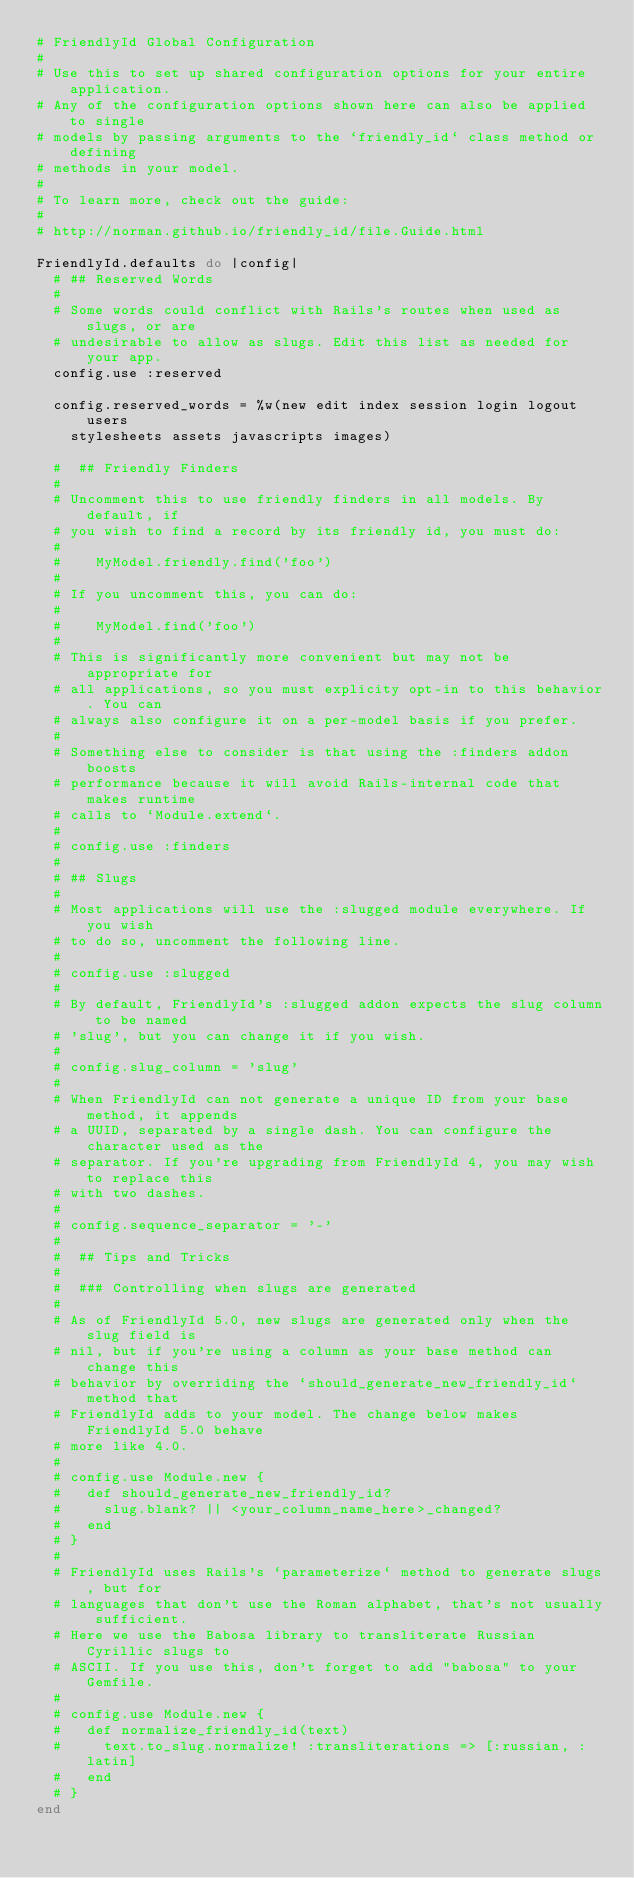Convert code to text. <code><loc_0><loc_0><loc_500><loc_500><_Ruby_># FriendlyId Global Configuration
#
# Use this to set up shared configuration options for your entire application.
# Any of the configuration options shown here can also be applied to single
# models by passing arguments to the `friendly_id` class method or defining
# methods in your model.
#
# To learn more, check out the guide:
#
# http://norman.github.io/friendly_id/file.Guide.html

FriendlyId.defaults do |config|
  # ## Reserved Words
  #
  # Some words could conflict with Rails's routes when used as slugs, or are
  # undesirable to allow as slugs. Edit this list as needed for your app.
  config.use :reserved

  config.reserved_words = %w(new edit index session login logout users
    stylesheets assets javascripts images)

  #  ## Friendly Finders
  #
  # Uncomment this to use friendly finders in all models. By default, if
  # you wish to find a record by its friendly id, you must do:
  #
  #    MyModel.friendly.find('foo')
  #
  # If you uncomment this, you can do:
  #
  #    MyModel.find('foo')
  #
  # This is significantly more convenient but may not be appropriate for
  # all applications, so you must explicity opt-in to this behavior. You can
  # always also configure it on a per-model basis if you prefer.
  #
  # Something else to consider is that using the :finders addon boosts
  # performance because it will avoid Rails-internal code that makes runtime
  # calls to `Module.extend`.
  #
  # config.use :finders
  #
  # ## Slugs
  #
  # Most applications will use the :slugged module everywhere. If you wish
  # to do so, uncomment the following line.
  #
  # config.use :slugged
  #
  # By default, FriendlyId's :slugged addon expects the slug column to be named
  # 'slug', but you can change it if you wish.
  #
  # config.slug_column = 'slug'
  #
  # When FriendlyId can not generate a unique ID from your base method, it appends
  # a UUID, separated by a single dash. You can configure the character used as the
  # separator. If you're upgrading from FriendlyId 4, you may wish to replace this
  # with two dashes.
  #
  # config.sequence_separator = '-'
  #
  #  ## Tips and Tricks
  #
  #  ### Controlling when slugs are generated
  #
  # As of FriendlyId 5.0, new slugs are generated only when the slug field is
  # nil, but if you're using a column as your base method can change this
  # behavior by overriding the `should_generate_new_friendly_id` method that
  # FriendlyId adds to your model. The change below makes FriendlyId 5.0 behave
  # more like 4.0.
  #
  # config.use Module.new {
  #   def should_generate_new_friendly_id?
  #     slug.blank? || <your_column_name_here>_changed?
  #   end
  # }
  #
  # FriendlyId uses Rails's `parameterize` method to generate slugs, but for
  # languages that don't use the Roman alphabet, that's not usually sufficient.
  # Here we use the Babosa library to transliterate Russian Cyrillic slugs to
  # ASCII. If you use this, don't forget to add "babosa" to your Gemfile.
  #
  # config.use Module.new {
  #   def normalize_friendly_id(text)
  #     text.to_slug.normalize! :transliterations => [:russian, :latin]
  #   end
  # }
end
</code> 